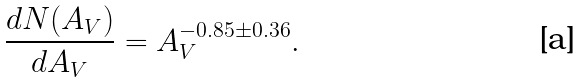Convert formula to latex. <formula><loc_0><loc_0><loc_500><loc_500>\frac { d N ( A _ { V } ) } { d A _ { V } } = A _ { V } ^ { - 0 . 8 5 \pm 0 . 3 6 } .</formula> 